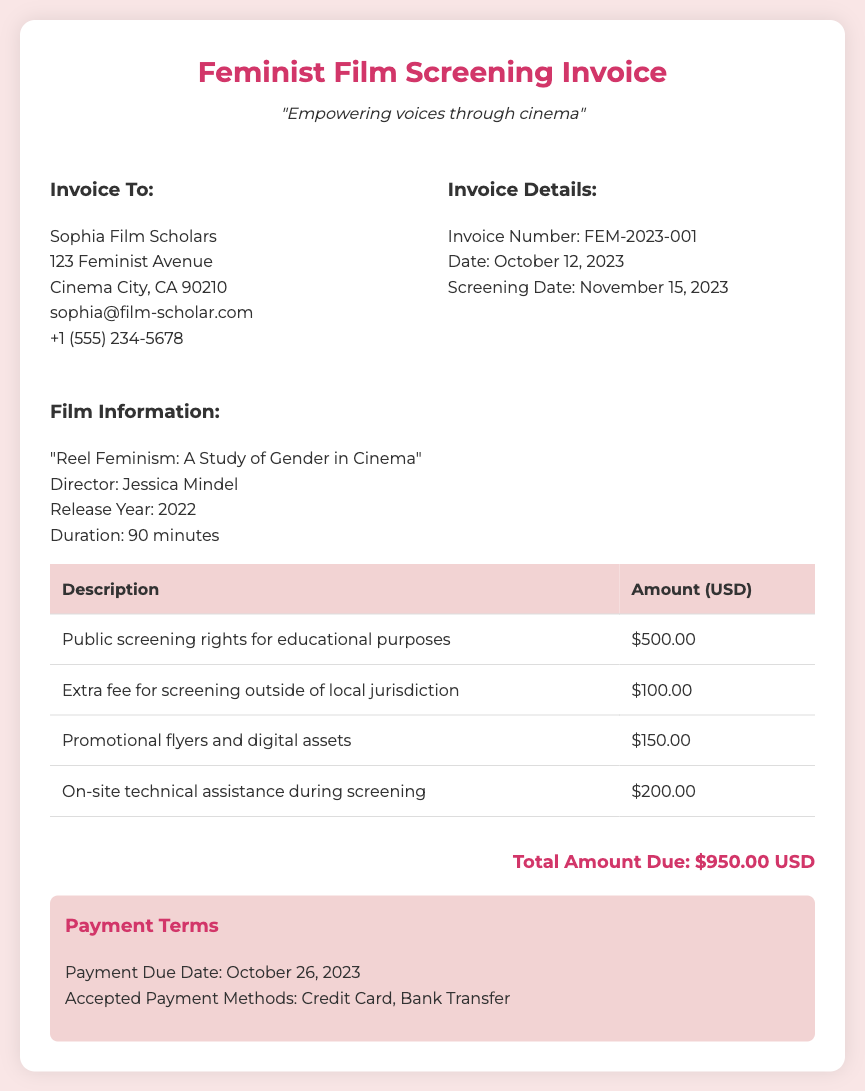What is the total amount due? The total amount due is listed at the bottom of the invoice as $950.00 USD.
Answer: $950.00 USD Who is the invoice addressed to? The invoice is addressed to Sophia Film Scholars, as stated in the invoice details section.
Answer: Sophia Film Scholars What is the screening date? The screening date is mentioned in the invoice details section as November 15, 2023.
Answer: November 15, 2023 What is the extra fee for screening outside of local jurisdiction? The extra fee for screening outside of local jurisdiction is provided as $100.00.
Answer: $100.00 What type of film is being screened? The film title provided in the document is "Reel Feminism: A Study of Gender in Cinema."
Answer: "Reel Feminism: A Study of Gender in Cinema" How much is the fee for promotional materials? The fee for promotional flyers and digital assets is detailed as $150.00.
Answer: $150.00 What is the payment due date? The payment due date is stated as October 26, 2023.
Answer: October 26, 2023 Who is the director of the film? The director of the film is listed as Jessica Mindel.
Answer: Jessica Mindel 